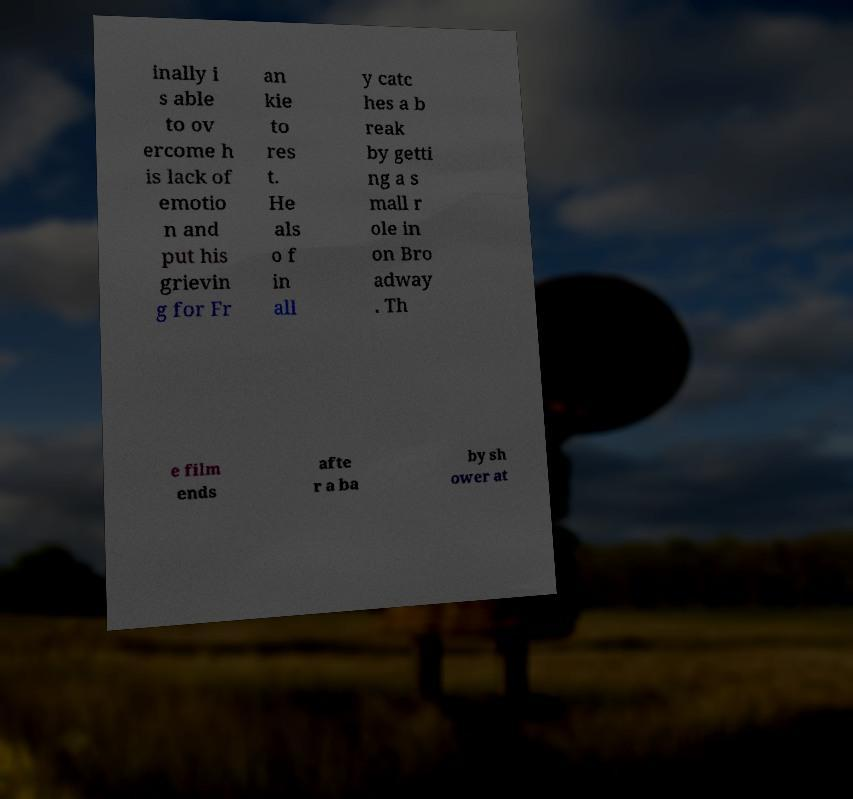Please read and relay the text visible in this image. What does it say? inally i s able to ov ercome h is lack of emotio n and put his grievin g for Fr an kie to res t. He als o f in all y catc hes a b reak by getti ng a s mall r ole in on Bro adway . Th e film ends afte r a ba by sh ower at 